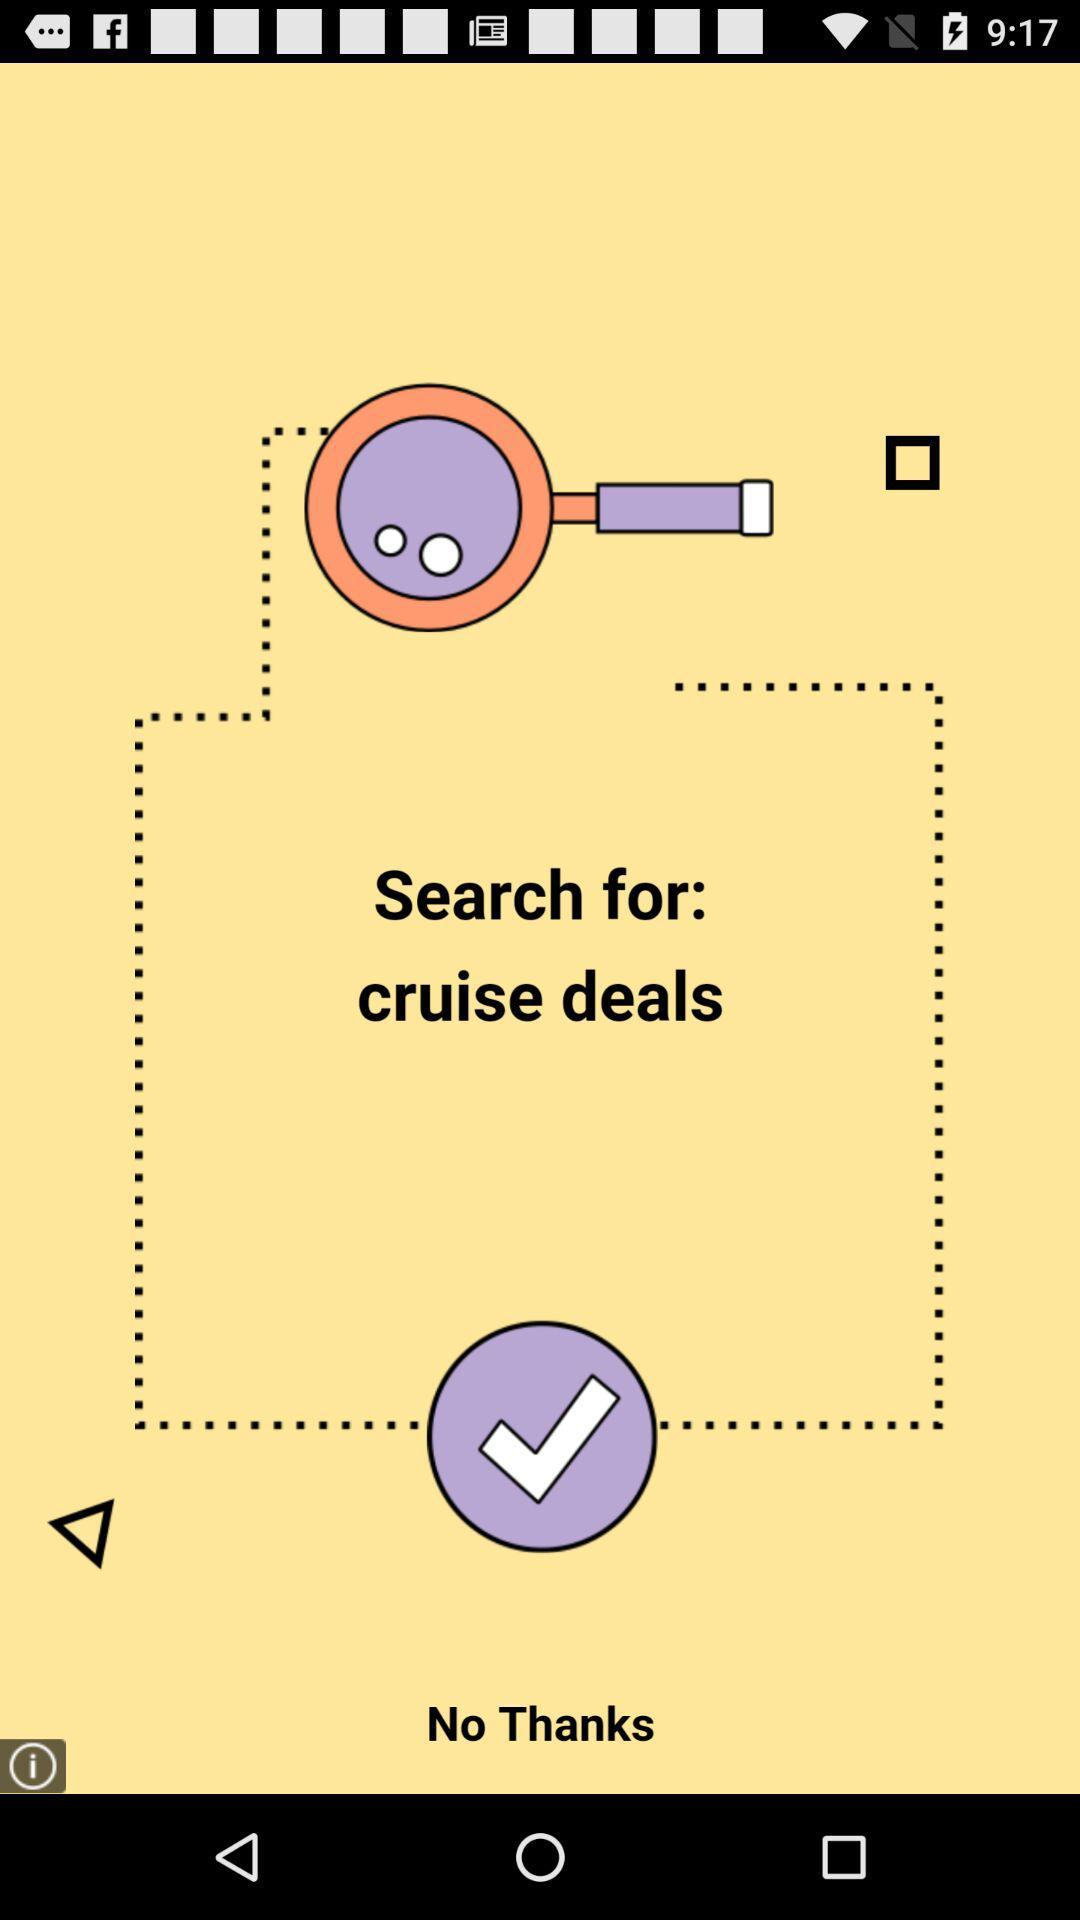What is the application name? The application name is "Mod PokeCraft PE". 